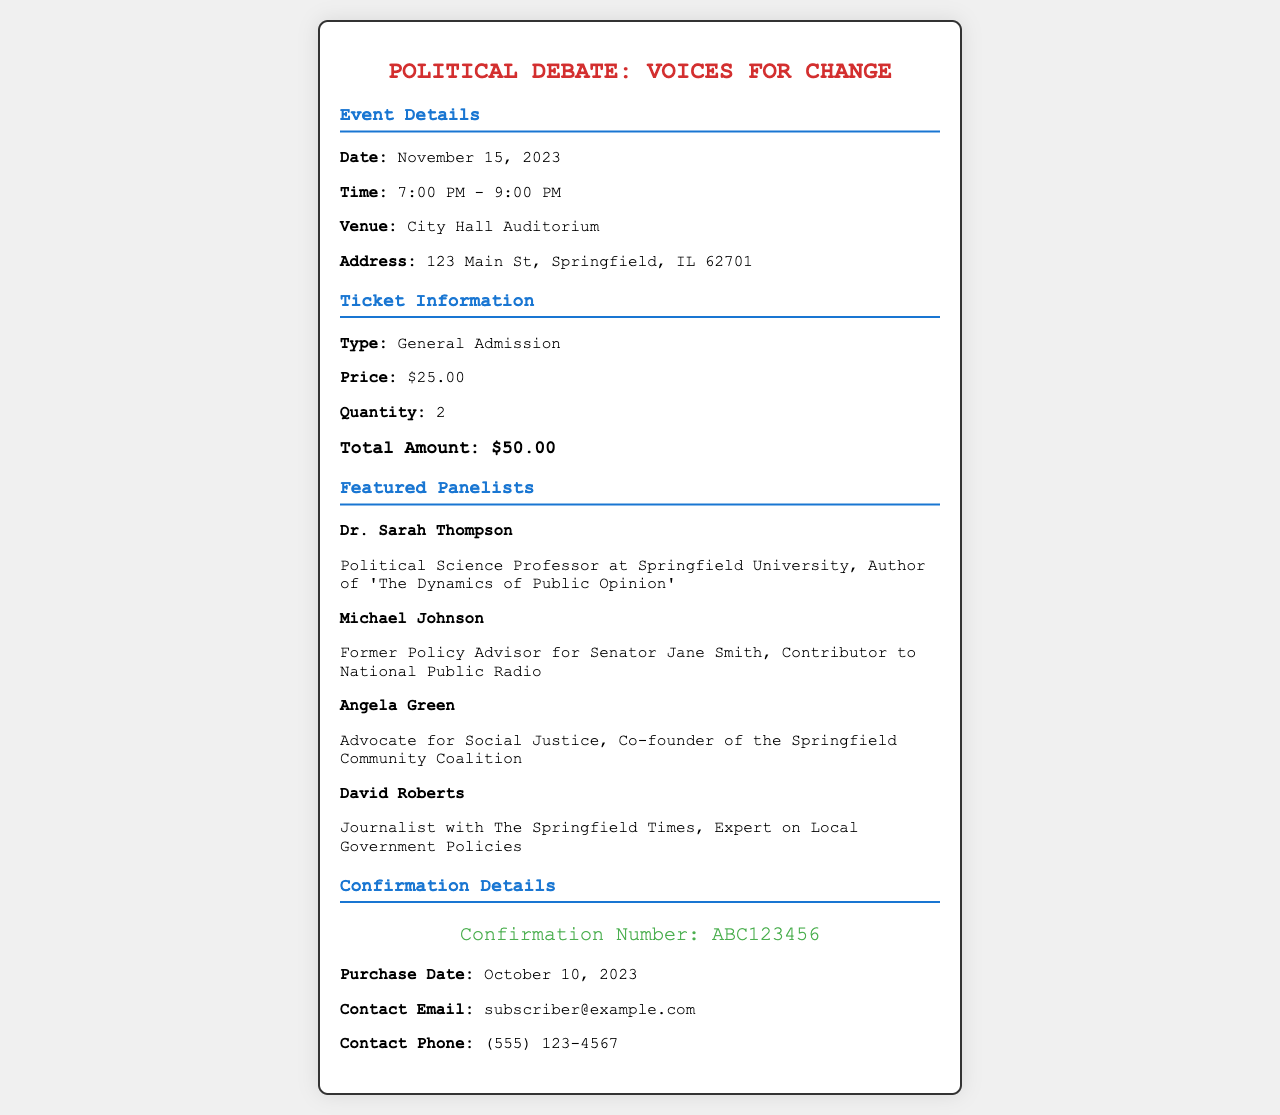What is the event title? The event title is the main heading of the document, indicating the topic of the debate.
Answer: Political Debate: Voices for Change What date is the event scheduled for? The date is specified under the event details section of the document.
Answer: November 15, 2023 How much is the ticket price? The ticket price is mentioned in the ticket information section of the document.
Answer: $25.00 How many tickets were purchased? The quantity of tickets is indicated in the ticket information section.
Answer: 2 Who is a featured panelist? Each mentioned panelist is listed in the panelists section.
Answer: Dr. Sarah Thompson What is the confirmation number? The confirmation number is found in the confirmation details section.
Answer: ABC123456 What is the total amount paid for the tickets? The total amount is calculated from the ticket price and quantity in the ticket information section.
Answer: $50.00 What time does the event start? The starting time is outlined in the event details section of the document.
Answer: 7:00 PM How can attendees contact regarding their purchase? Contact information is provided in the confirmation details section of the document.
Answer: subscriber@example.com 